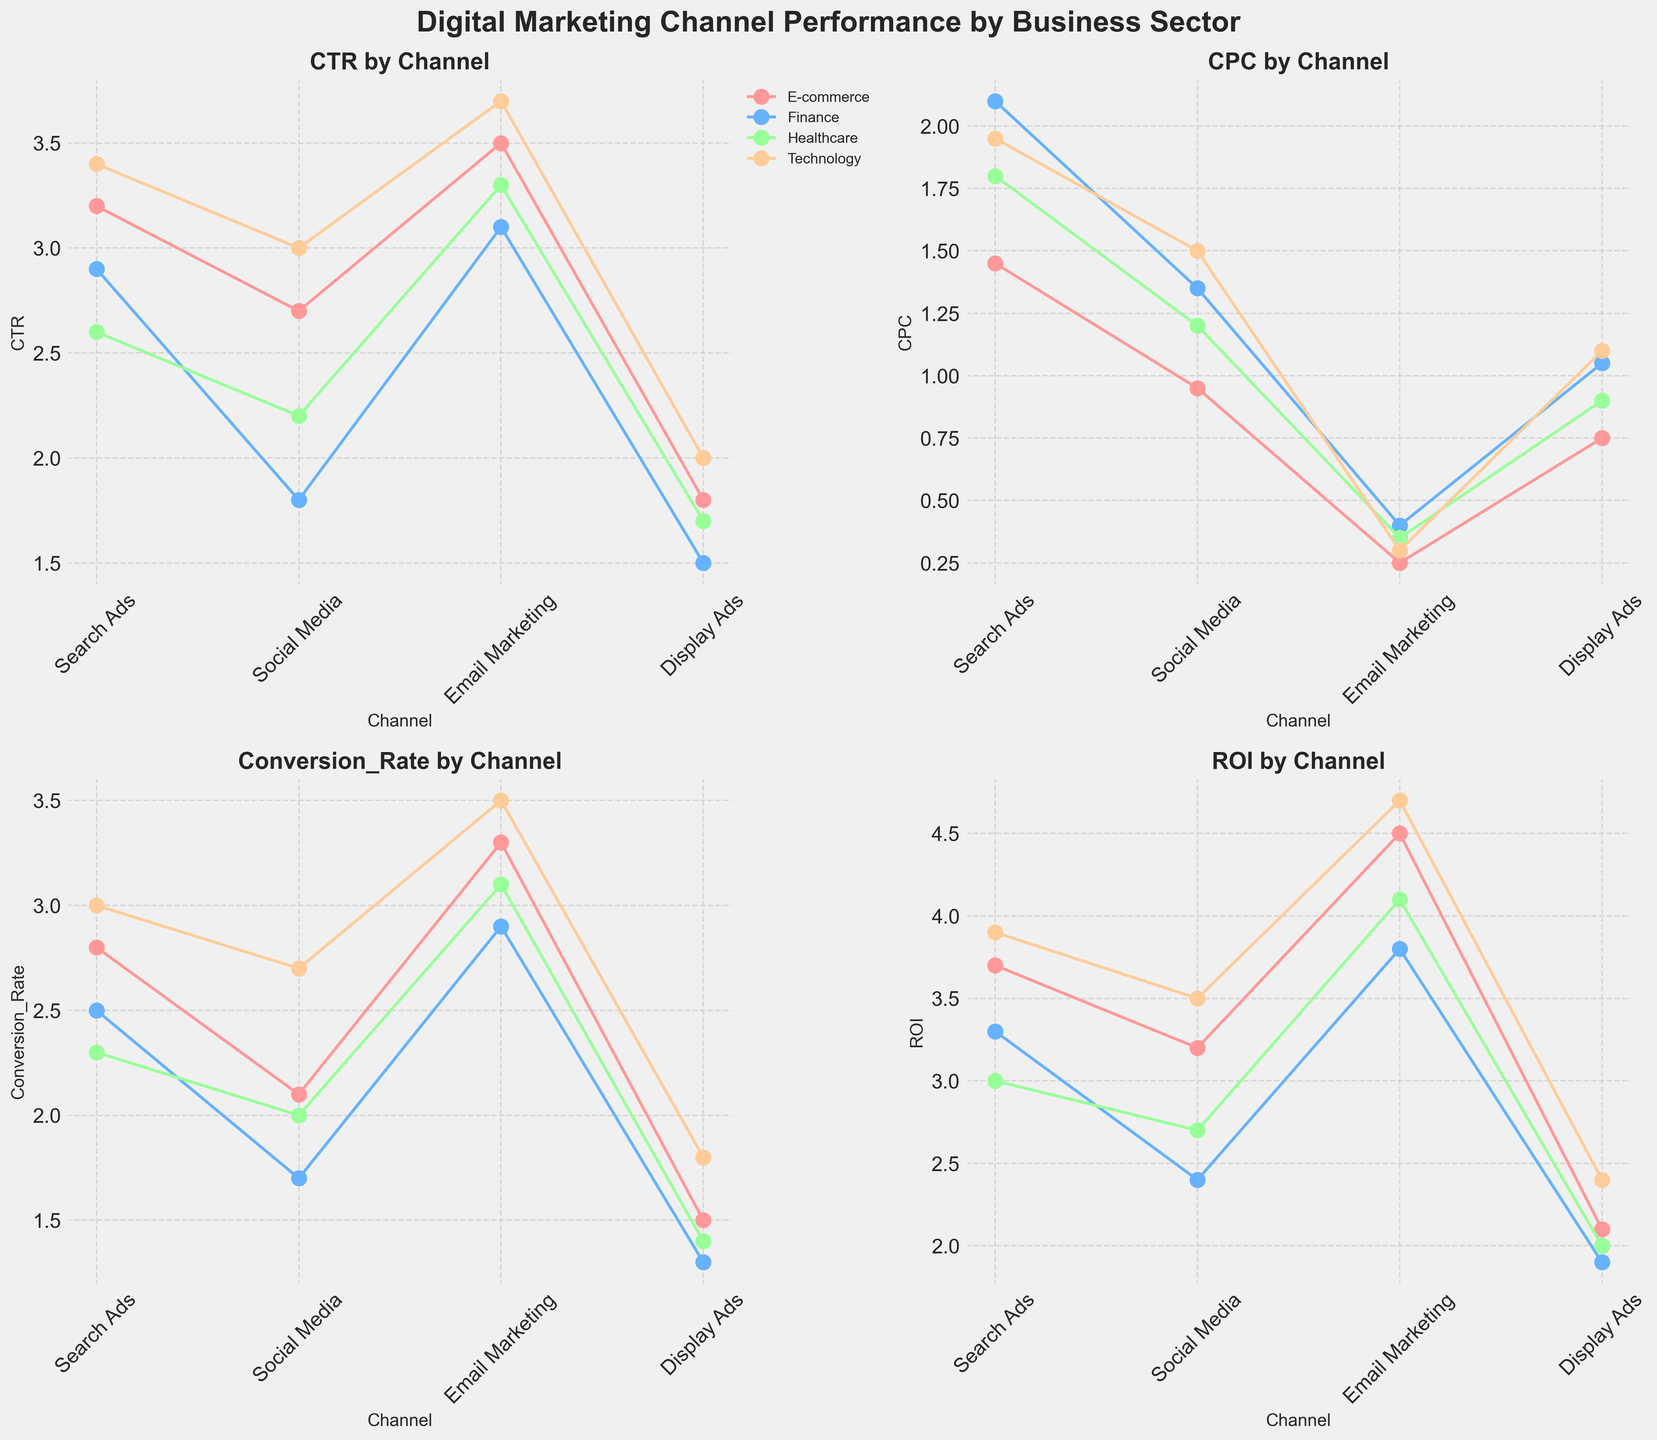What is the title of the figure? The title is presented at the top of the figure in a larger and bolder font size. It provides a summary of what the figure is about.
Answer: Digital Marketing Channel Performance by Business Sector Which marketing channel has the highest CTR in the Healthcare sector? Look at the plot for CTR by Channel and find the highest point for the Healthcare sector.
Answer: Email Marketing How does the CPC of Display Ads compare between the Finance and E-commerce sectors? Observe the CPC by Channel plot and compare the values of Display Ads for both sectors. The marker positions indicate the CPC values.
Answer: Higher in Finance Which sector has the highest ROI for Search Ads? Check the ROI by Channel plot and identify the sector with the highest point for Search Ads.
Answer: Technology What is the average Conversion Rate for Social Media across all sectors? Locate the Conversion Rate by Channel plot, record the Conversion Rate values for Social Media in all sectors, sum them up and divide by the number of sectors.
Answer: (2.1+1.7+2.0+2.7)/4 = 2.125 Which sector has the most consistent performance across different metrics for Email Marketing? Investigate all subplots (CTR, CPC, Conversion Rate, and ROI) and observe which sector shows the least variation in its values for Email Marketing across these plots.
Answer: E-commerce In which sector is the difference between the highest and lowest ROI values the greatest? For each sector, calculate the difference between the highest and lowest ROI values across all channels. Compare these differences across sectors.
Answer: Technology How does the Conversion Rate of Email Marketing in the Technology sector compare to that in the Finance sector? Refer to the Conversion Rate by Channel plot and compare the values of Email Marketing for Technology and Finance sectors.
Answer: Higher in Technology Which marketing channel has the lowest CPC in all sectors? Spot the lowest points in the CPC by Channel plot for each sector and identify the channel.
Answer: Email Marketing How many sectors are included in the figure? Count the number of unique sectors shown in the legends of each subplot.
Answer: Four 